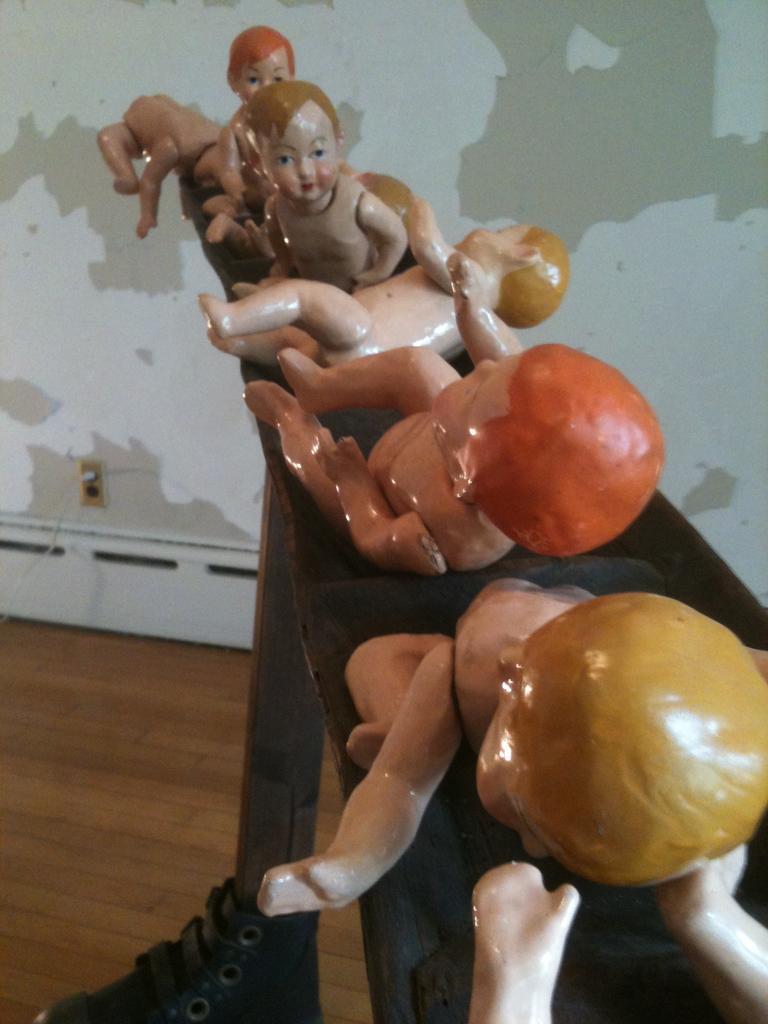Describe this image in one or two sentences. In this image, we can see some kids statues, there is a brown color floor and in the background there is a wall. 